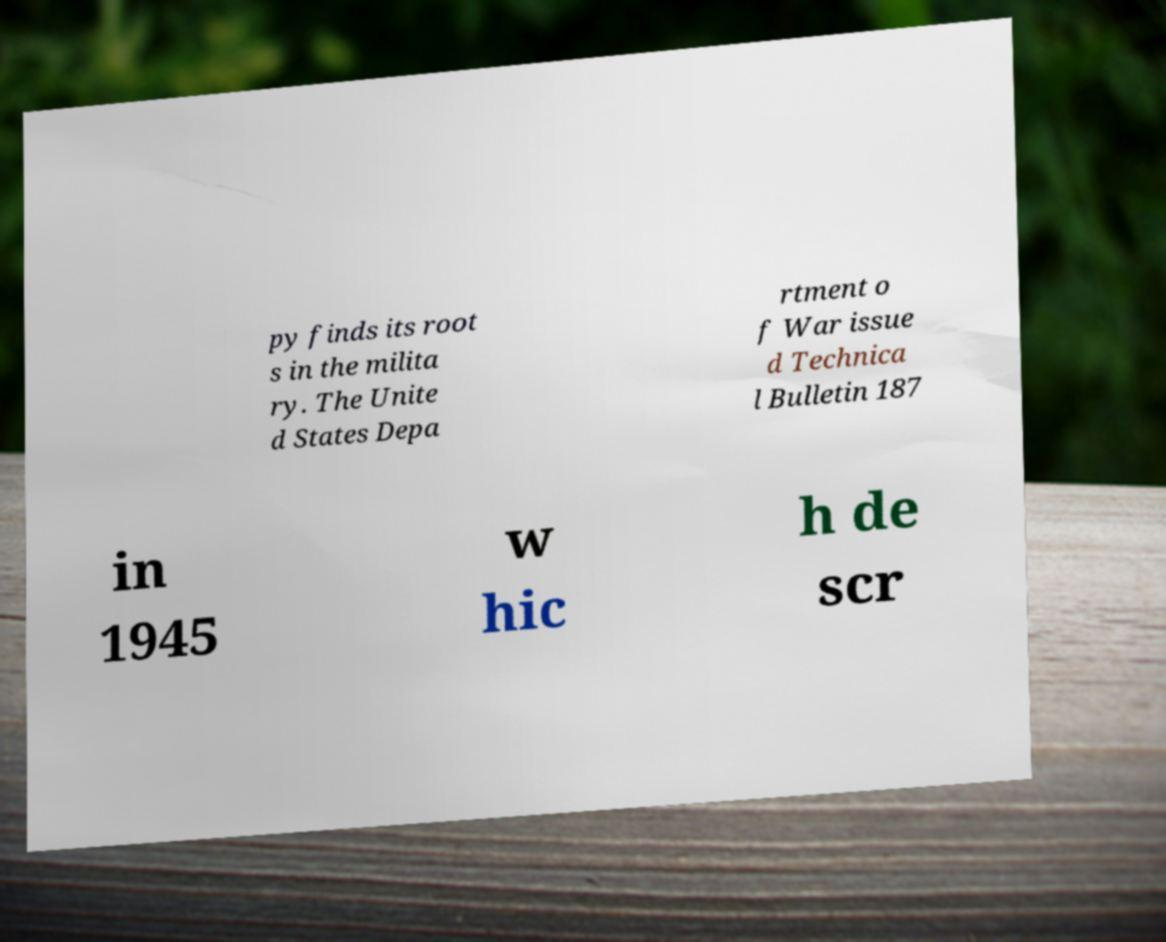Can you accurately transcribe the text from the provided image for me? py finds its root s in the milita ry. The Unite d States Depa rtment o f War issue d Technica l Bulletin 187 in 1945 w hic h de scr 